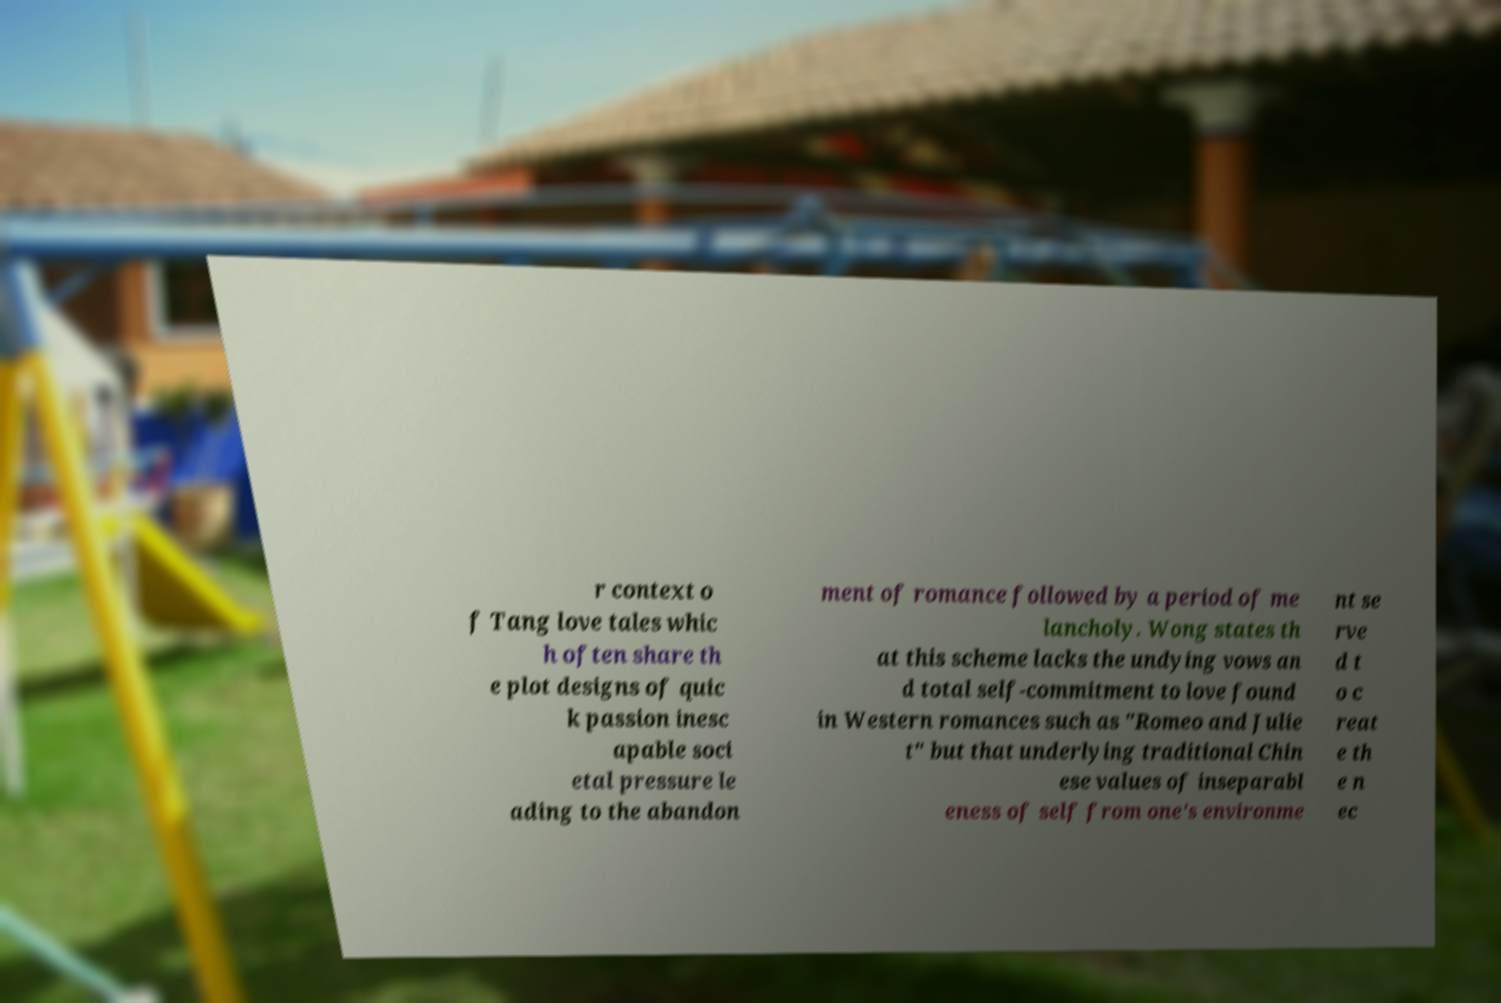What messages or text are displayed in this image? I need them in a readable, typed format. r context o f Tang love tales whic h often share th e plot designs of quic k passion inesc apable soci etal pressure le ading to the abandon ment of romance followed by a period of me lancholy. Wong states th at this scheme lacks the undying vows an d total self-commitment to love found in Western romances such as "Romeo and Julie t" but that underlying traditional Chin ese values of inseparabl eness of self from one's environme nt se rve d t o c reat e th e n ec 